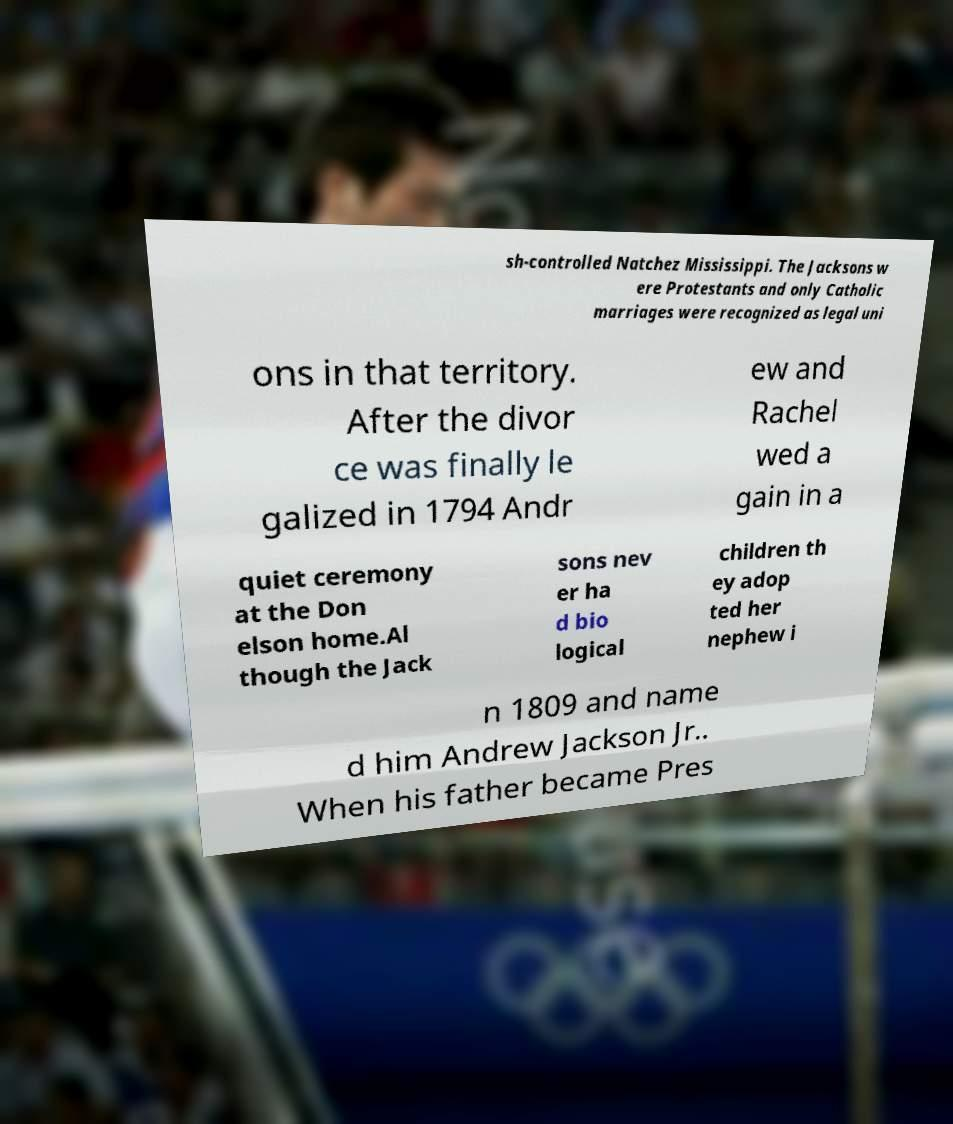For documentation purposes, I need the text within this image transcribed. Could you provide that? sh-controlled Natchez Mississippi. The Jacksons w ere Protestants and only Catholic marriages were recognized as legal uni ons in that territory. After the divor ce was finally le galized in 1794 Andr ew and Rachel wed a gain in a quiet ceremony at the Don elson home.Al though the Jack sons nev er ha d bio logical children th ey adop ted her nephew i n 1809 and name d him Andrew Jackson Jr.. When his father became Pres 